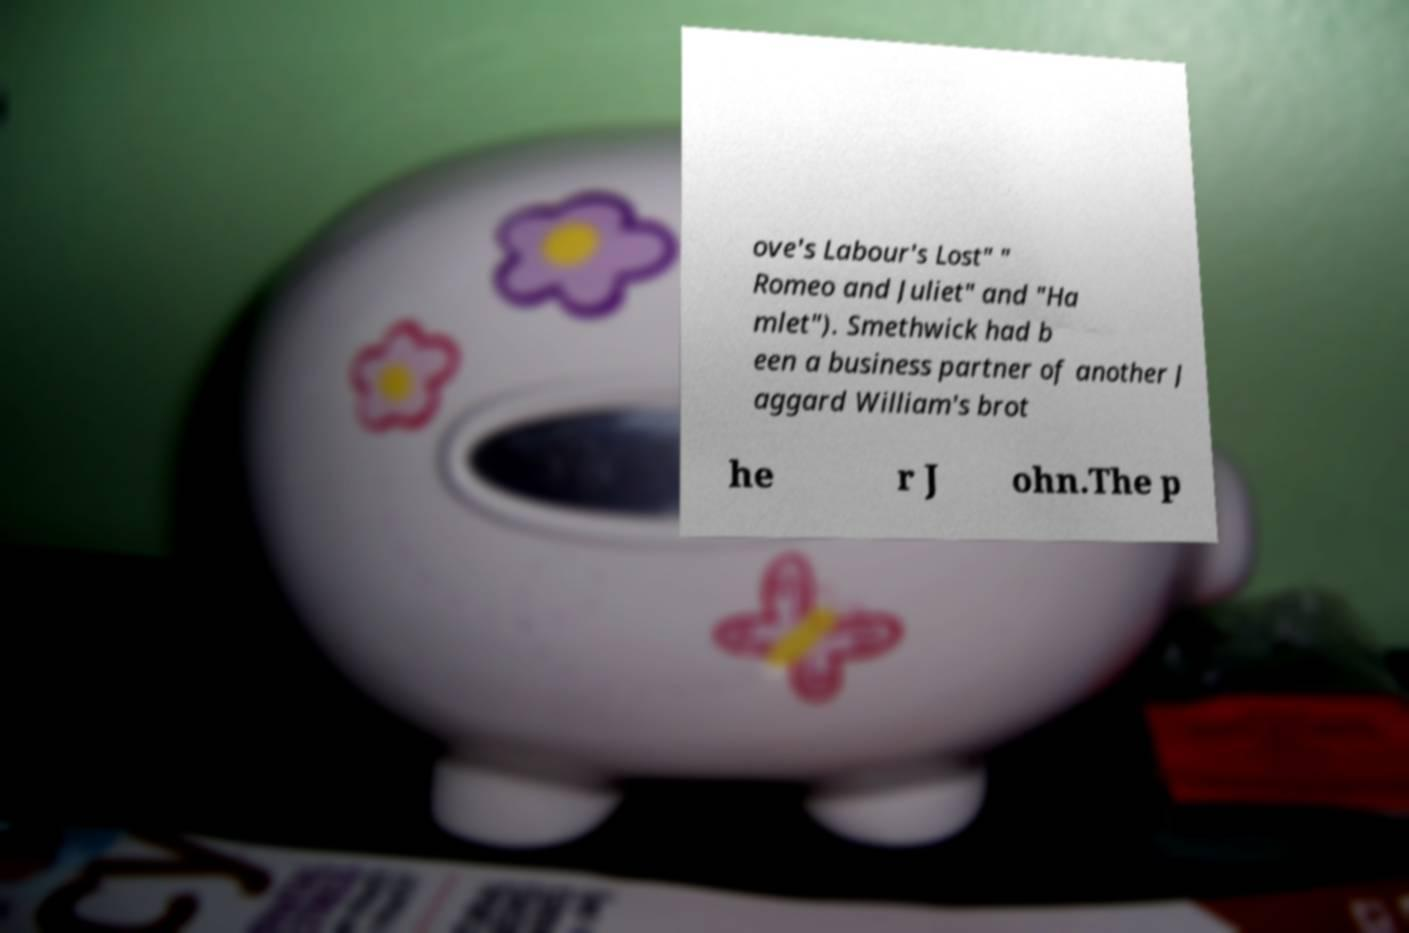Could you extract and type out the text from this image? ove's Labour's Lost" " Romeo and Juliet" and "Ha mlet"). Smethwick had b een a business partner of another J aggard William's brot he r J ohn.The p 